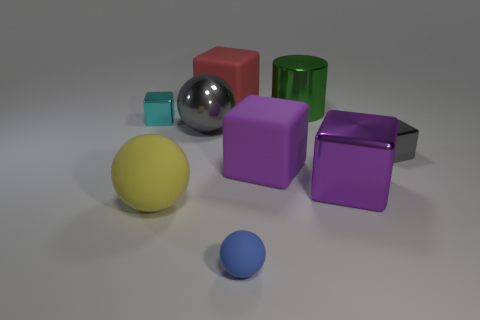How many other objects are there of the same material as the cyan object?
Provide a short and direct response. 4. Is the size of the blue thing the same as the green cylinder?
Your response must be concise. No. There is a green thing that is the same size as the yellow object; what is its shape?
Keep it short and to the point. Cylinder. There is a thing left of the yellow matte object; is its size the same as the gray block?
Provide a short and direct response. Yes. What material is the other sphere that is the same size as the gray ball?
Your response must be concise. Rubber. There is a rubber object that is to the left of the large cube that is behind the cyan metal block; is there a purple metal cube that is on the left side of it?
Provide a succinct answer. No. Is there anything else that is the same shape as the tiny blue rubber thing?
Provide a succinct answer. Yes. Does the rubber ball that is on the right side of the large red rubber block have the same color as the small block on the left side of the large cylinder?
Offer a terse response. No. Are there any small cyan cubes?
Provide a short and direct response. Yes. What material is the small cube that is the same color as the metal ball?
Provide a succinct answer. Metal. 